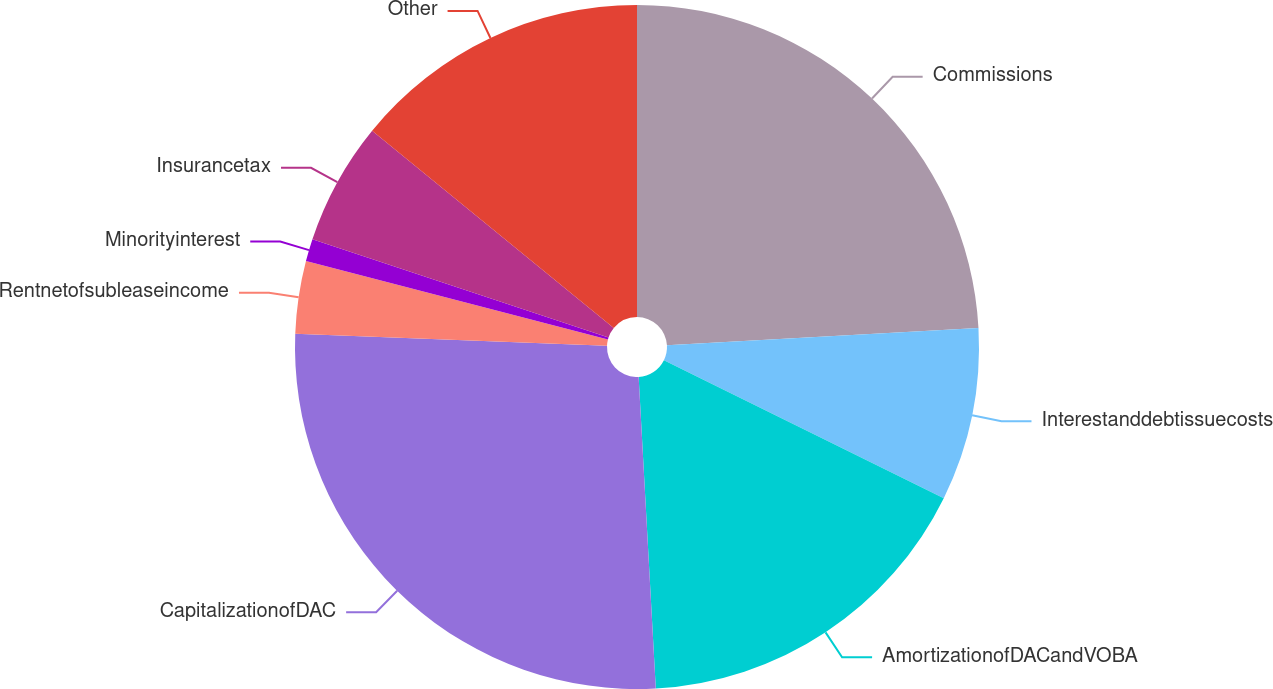<chart> <loc_0><loc_0><loc_500><loc_500><pie_chart><fcel>Commissions<fcel>Interestanddebtissuecosts<fcel>AmortizationofDACandVOBA<fcel>CapitalizationofDAC<fcel>Rentnetofsubleaseincome<fcel>Minorityinterest<fcel>Insurancetax<fcel>Other<nl><fcel>24.12%<fcel>8.17%<fcel>16.84%<fcel>26.49%<fcel>3.43%<fcel>1.06%<fcel>5.8%<fcel>14.1%<nl></chart> 